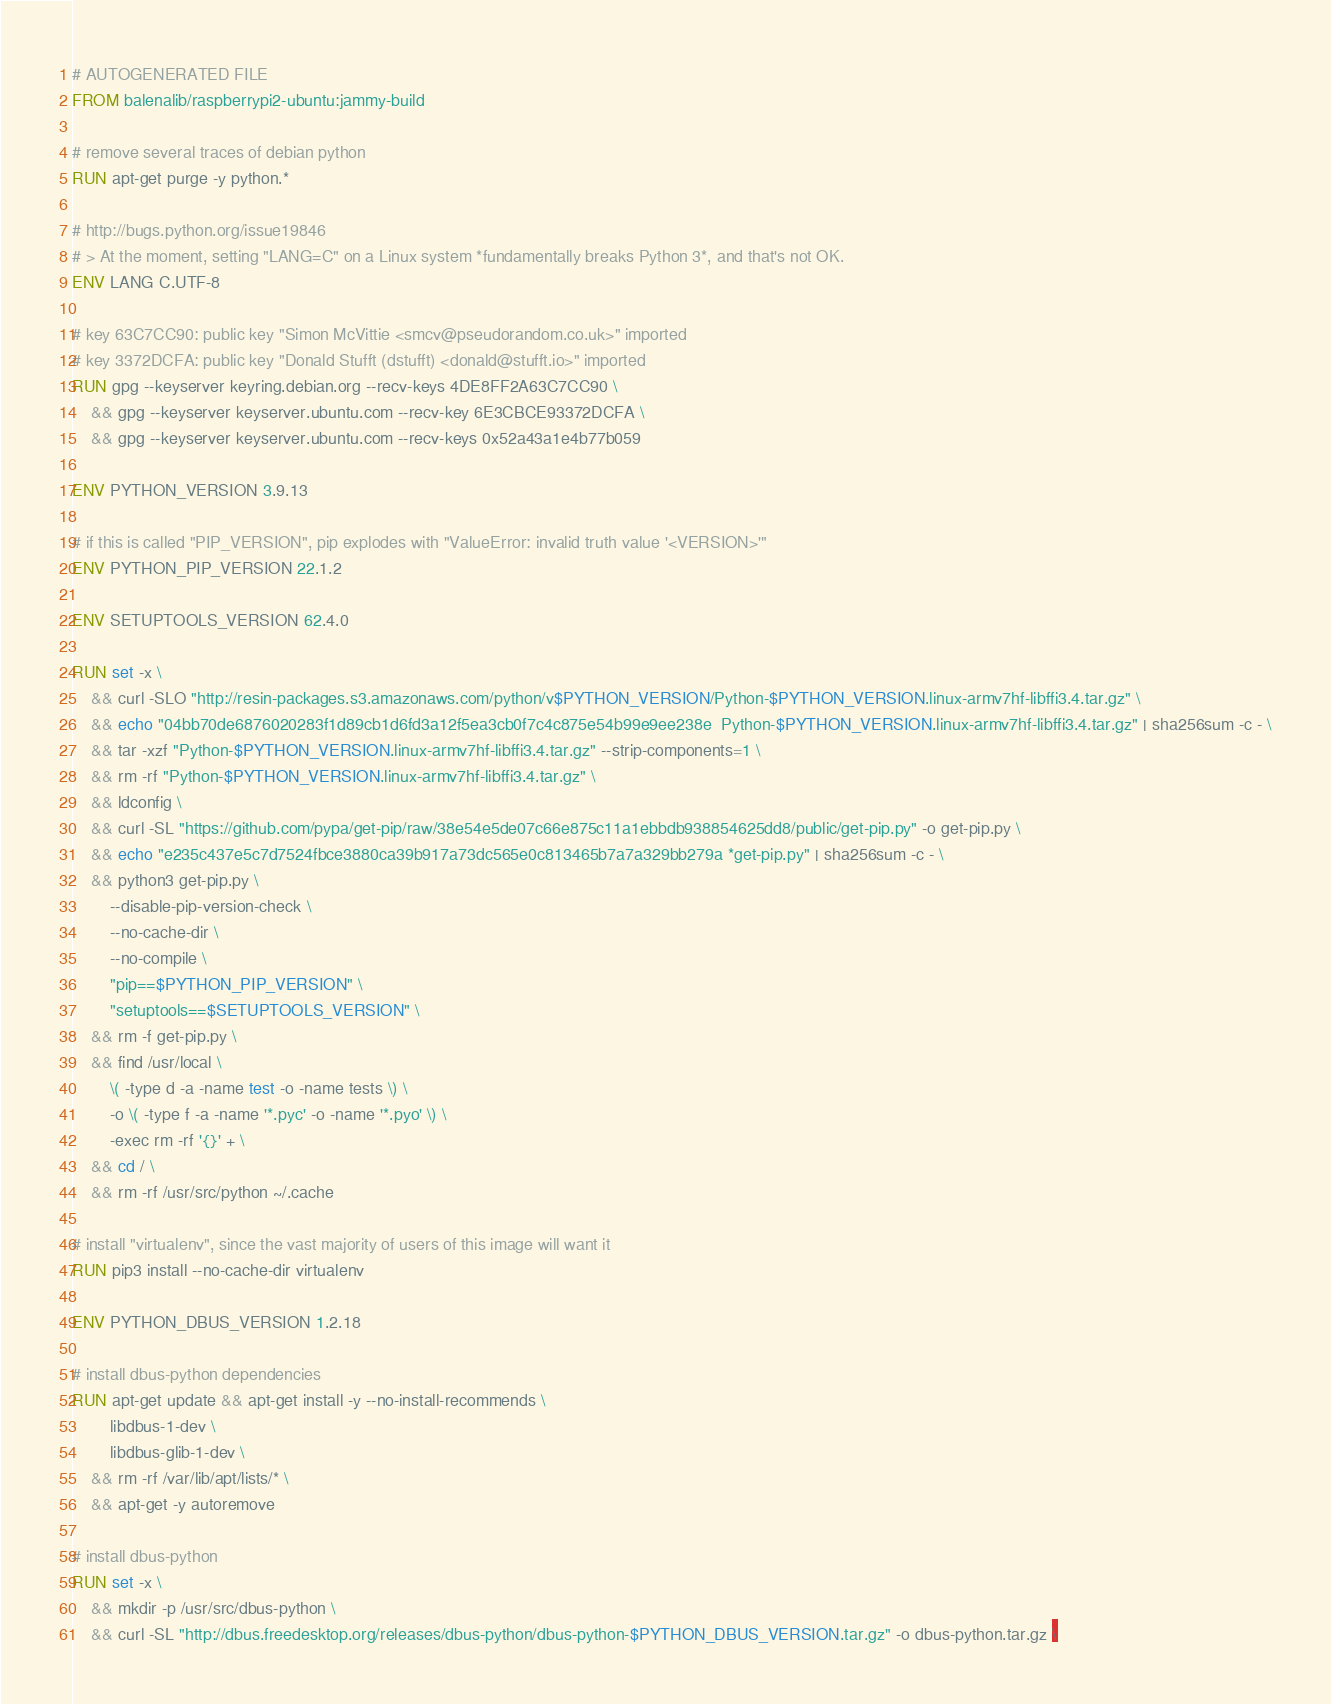Convert code to text. <code><loc_0><loc_0><loc_500><loc_500><_Dockerfile_># AUTOGENERATED FILE
FROM balenalib/raspberrypi2-ubuntu:jammy-build

# remove several traces of debian python
RUN apt-get purge -y python.*

# http://bugs.python.org/issue19846
# > At the moment, setting "LANG=C" on a Linux system *fundamentally breaks Python 3*, and that's not OK.
ENV LANG C.UTF-8

# key 63C7CC90: public key "Simon McVittie <smcv@pseudorandom.co.uk>" imported
# key 3372DCFA: public key "Donald Stufft (dstufft) <donald@stufft.io>" imported
RUN gpg --keyserver keyring.debian.org --recv-keys 4DE8FF2A63C7CC90 \
	&& gpg --keyserver keyserver.ubuntu.com --recv-key 6E3CBCE93372DCFA \
	&& gpg --keyserver keyserver.ubuntu.com --recv-keys 0x52a43a1e4b77b059

ENV PYTHON_VERSION 3.9.13

# if this is called "PIP_VERSION", pip explodes with "ValueError: invalid truth value '<VERSION>'"
ENV PYTHON_PIP_VERSION 22.1.2

ENV SETUPTOOLS_VERSION 62.4.0

RUN set -x \
	&& curl -SLO "http://resin-packages.s3.amazonaws.com/python/v$PYTHON_VERSION/Python-$PYTHON_VERSION.linux-armv7hf-libffi3.4.tar.gz" \
	&& echo "04bb70de6876020283f1d89cb1d6fd3a12f5ea3cb0f7c4c875e54b99e9ee238e  Python-$PYTHON_VERSION.linux-armv7hf-libffi3.4.tar.gz" | sha256sum -c - \
	&& tar -xzf "Python-$PYTHON_VERSION.linux-armv7hf-libffi3.4.tar.gz" --strip-components=1 \
	&& rm -rf "Python-$PYTHON_VERSION.linux-armv7hf-libffi3.4.tar.gz" \
	&& ldconfig \
	&& curl -SL "https://github.com/pypa/get-pip/raw/38e54e5de07c66e875c11a1ebbdb938854625dd8/public/get-pip.py" -o get-pip.py \
    && echo "e235c437e5c7d7524fbce3880ca39b917a73dc565e0c813465b7a7a329bb279a *get-pip.py" | sha256sum -c - \
    && python3 get-pip.py \
        --disable-pip-version-check \
        --no-cache-dir \
        --no-compile \
        "pip==$PYTHON_PIP_VERSION" \
        "setuptools==$SETUPTOOLS_VERSION" \
	&& rm -f get-pip.py \
	&& find /usr/local \
		\( -type d -a -name test -o -name tests \) \
		-o \( -type f -a -name '*.pyc' -o -name '*.pyo' \) \
		-exec rm -rf '{}' + \
	&& cd / \
	&& rm -rf /usr/src/python ~/.cache

# install "virtualenv", since the vast majority of users of this image will want it
RUN pip3 install --no-cache-dir virtualenv

ENV PYTHON_DBUS_VERSION 1.2.18

# install dbus-python dependencies 
RUN apt-get update && apt-get install -y --no-install-recommends \
		libdbus-1-dev \
		libdbus-glib-1-dev \
	&& rm -rf /var/lib/apt/lists/* \
	&& apt-get -y autoremove

# install dbus-python
RUN set -x \
	&& mkdir -p /usr/src/dbus-python \
	&& curl -SL "http://dbus.freedesktop.org/releases/dbus-python/dbus-python-$PYTHON_DBUS_VERSION.tar.gz" -o dbus-python.tar.gz \</code> 